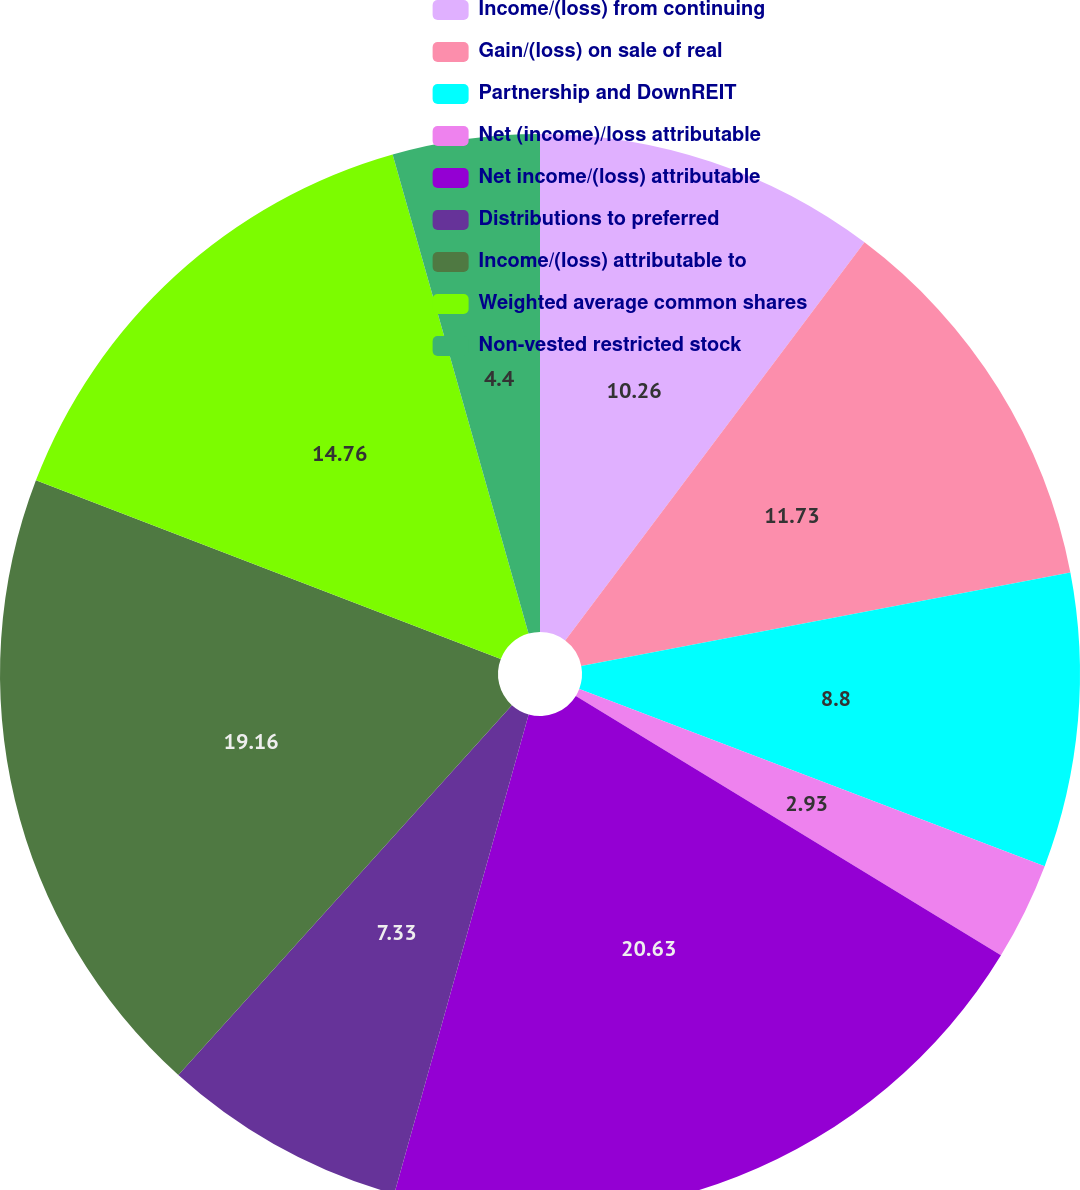<chart> <loc_0><loc_0><loc_500><loc_500><pie_chart><fcel>Income/(loss) from continuing<fcel>Gain/(loss) on sale of real<fcel>Partnership and DownREIT<fcel>Net (income)/loss attributable<fcel>Net income/(loss) attributable<fcel>Distributions to preferred<fcel>Income/(loss) attributable to<fcel>Weighted average common shares<fcel>Non-vested restricted stock<nl><fcel>10.26%<fcel>11.73%<fcel>8.8%<fcel>2.93%<fcel>20.63%<fcel>7.33%<fcel>19.16%<fcel>14.76%<fcel>4.4%<nl></chart> 